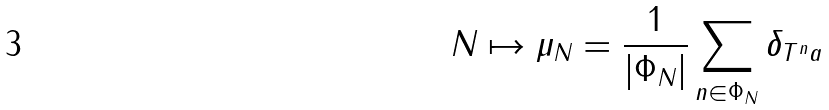<formula> <loc_0><loc_0><loc_500><loc_500>N \mapsto \mu _ { N } = \frac { 1 } { | \Phi _ { N } | } \sum _ { n \in \Phi _ { N } } \delta _ { T ^ { n } a }</formula> 